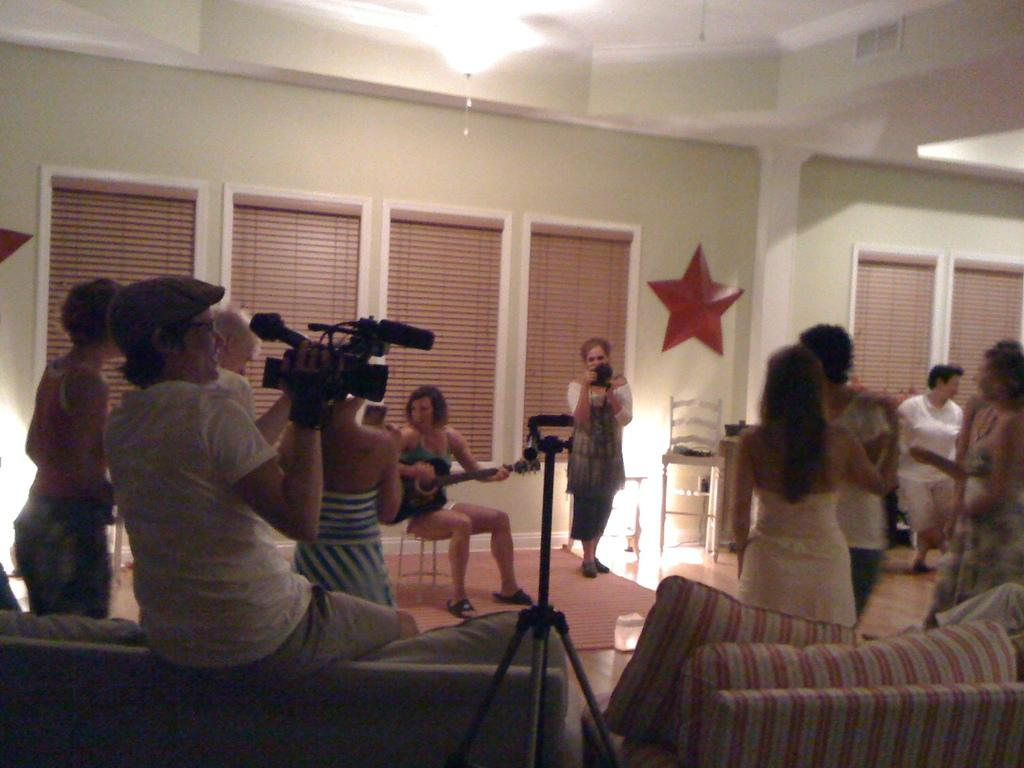What activities are the people in the room engaged in? Some people are dancing, playing musical instruments, and taking pictures. Can you describe the different roles of the people in the room? Some people are dancing, while others are playing musical instruments or taking pictures. How many activities are taking place in the room? There are three activities taking place in the room: dancing, playing musical instruments, and taking pictures. What is the profit made by the people in the room? There is no mention of profit in the image, as it focuses on the activities of the people in the room. 